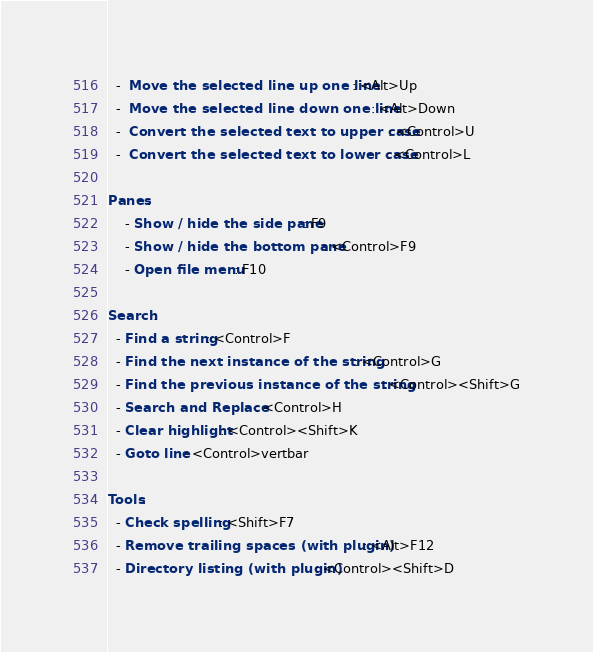Convert code to text. <code><loc_0><loc_0><loc_500><loc_500><_YAML_>  -  Move the selected line up one line: <Alt>Up
  -  Move the selected line down one line: <Alt>Down
  -  Convert the selected text to upper case: <Control>U
  -  Convert the selected text to lower case: <Control>L

Panes:
    - Show / hide the side pane: F9
    - Show / hide the bottom pane: <Control>F9
    - Open file menu: F10

Search:
  - Find a string: <Control>F    
  - Find the next instance of the string: <Control>G
  - Find the previous instance of the string: <Control><Shift>G
  - Search and Replace: <Control>H
  - Clear highlight: <Control><Shift>K
  - Goto line: <Control>vertbar

Tools:
  - Check spelling: <Shift>F7
  - Remove trailing spaces (with plugin): <Alt>F12
  - Directory listing (with plugin): <Control><Shift>D
</code> 